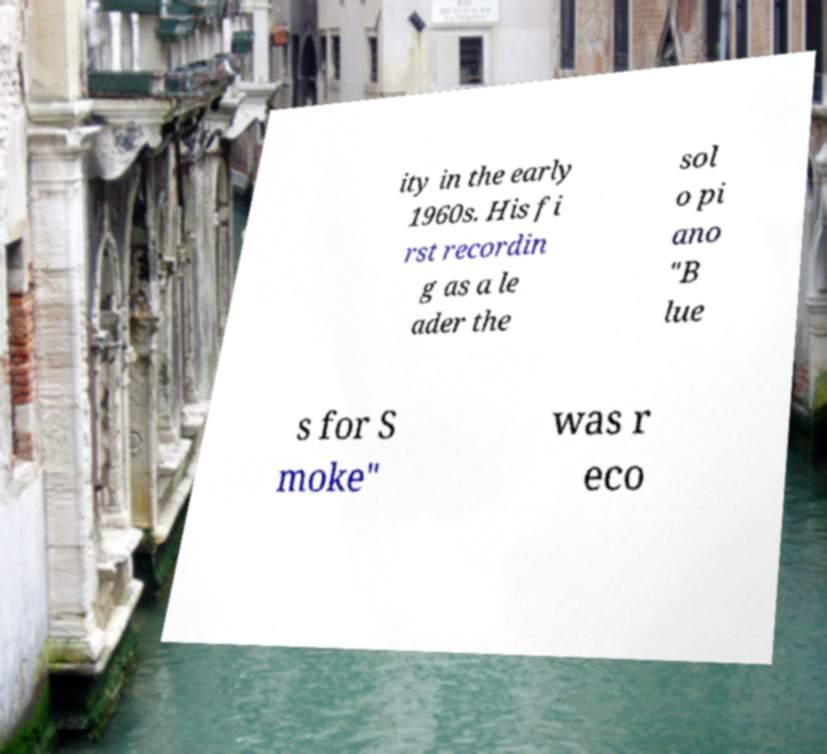Could you assist in decoding the text presented in this image and type it out clearly? ity in the early 1960s. His fi rst recordin g as a le ader the sol o pi ano "B lue s for S moke" was r eco 